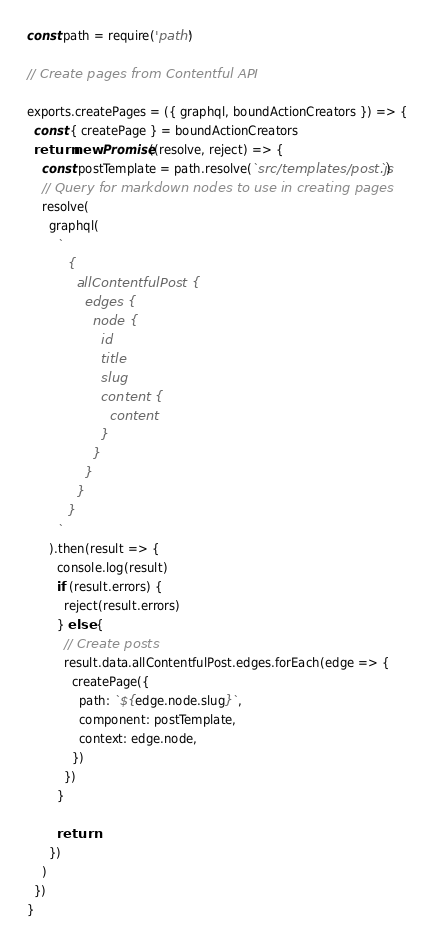Convert code to text. <code><loc_0><loc_0><loc_500><loc_500><_JavaScript_>const path = require('path')

// Create pages from Contentful API

exports.createPages = ({ graphql, boundActionCreators }) => {
  const { createPage } = boundActionCreators
  return new Promise((resolve, reject) => {
    const postTemplate = path.resolve(`src/templates/post.js`)
    // Query for markdown nodes to use in creating pages
    resolve(
      graphql(
        `
          {
            allContentfulPost {
              edges {
                node {
                  id
                  title
                  slug
                  content {
                    content
                  }
                }
              }
            }
          }
        `
      ).then(result => {
        console.log(result)
        if (result.errors) {
          reject(result.errors)
        } else {
          // Create posts
          result.data.allContentfulPost.edges.forEach(edge => {
            createPage({
              path: `${edge.node.slug}`,
              component: postTemplate,
              context: edge.node,
            })
          })
        }

        return
      })
    )
  })
}
</code> 